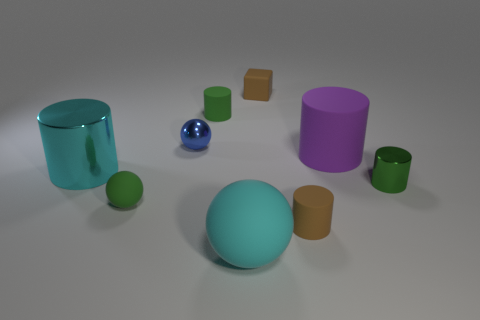Subtract all small matte cylinders. How many cylinders are left? 3 Subtract all cyan spheres. How many spheres are left? 2 Subtract all cubes. How many objects are left? 8 Subtract 2 spheres. How many spheres are left? 1 Subtract all cyan cylinders. Subtract all brown balls. How many cylinders are left? 4 Subtract all green balls. How many green cylinders are left? 2 Subtract all small brown objects. Subtract all large cyan metal cylinders. How many objects are left? 6 Add 3 tiny blue objects. How many tiny blue objects are left? 4 Add 1 big brown metal cylinders. How many big brown metal cylinders exist? 1 Subtract 1 brown cylinders. How many objects are left? 8 